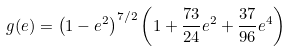Convert formula to latex. <formula><loc_0><loc_0><loc_500><loc_500>g ( e ) = \left ( 1 - e ^ { 2 } \right ) ^ { 7 / 2 } \left ( 1 + \frac { 7 3 } { 2 4 } e ^ { 2 } + \frac { 3 7 } { 9 6 } e ^ { 4 } \right )</formula> 